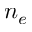<formula> <loc_0><loc_0><loc_500><loc_500>n _ { e }</formula> 